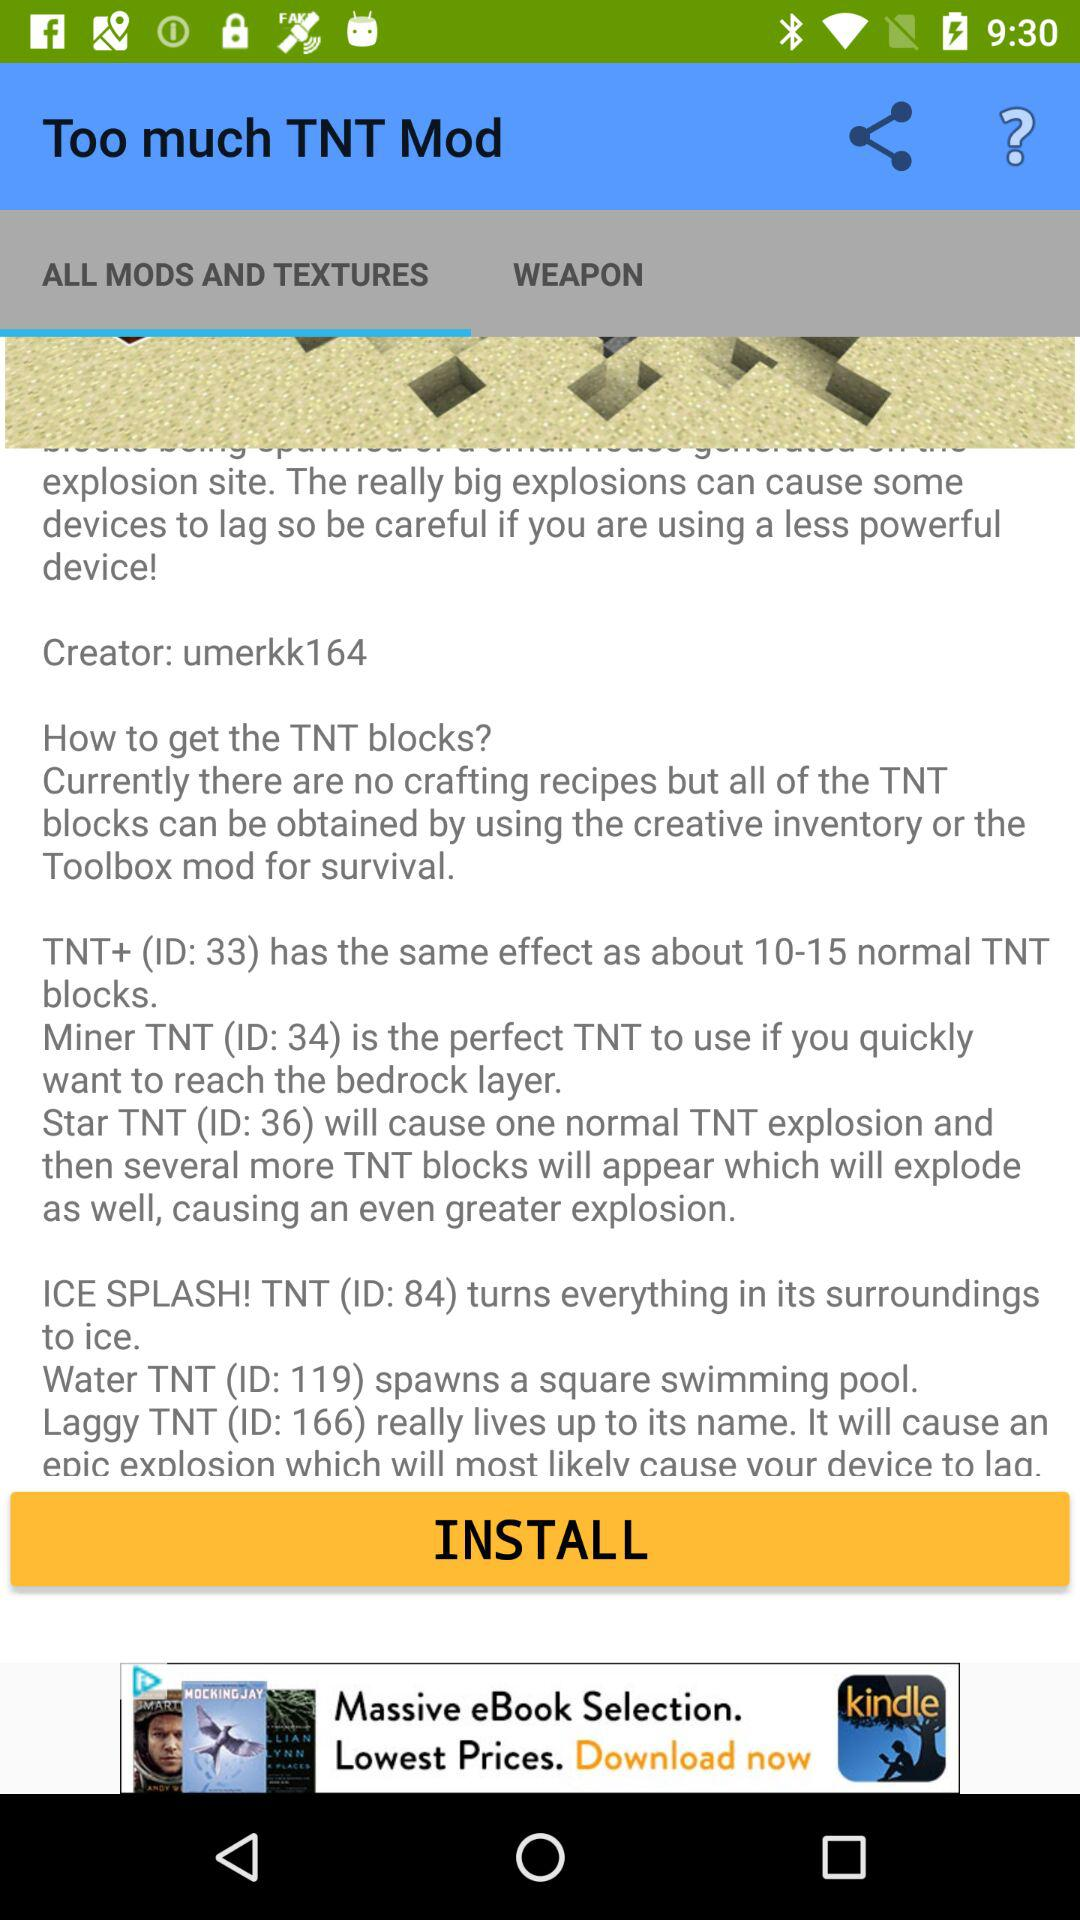How many different types of TNT blocks are there?
Answer the question using a single word or phrase. 6 